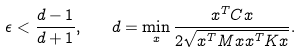<formula> <loc_0><loc_0><loc_500><loc_500>\epsilon < \frac { d - 1 } { d + 1 } , \quad d = \min _ { x } \frac { x ^ { T } C x } { 2 \sqrt { x ^ { T } M x x ^ { T } K x } } .</formula> 